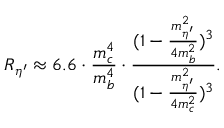Convert formula to latex. <formula><loc_0><loc_0><loc_500><loc_500>R _ { \eta ^ { \prime } } \approx 6 . 6 \cdot \frac { m _ { c } ^ { 4 } } { m _ { b } ^ { 4 } } \cdot \frac { ( 1 - \frac { m _ { \eta ^ { \prime } } ^ { 2 } } { 4 m _ { b } ^ { 2 } } ) ^ { 3 } } { ( 1 - \frac { m _ { \eta ^ { \prime } } ^ { 2 } } { 4 m _ { c } ^ { 2 } } ) ^ { 3 } } .</formula> 